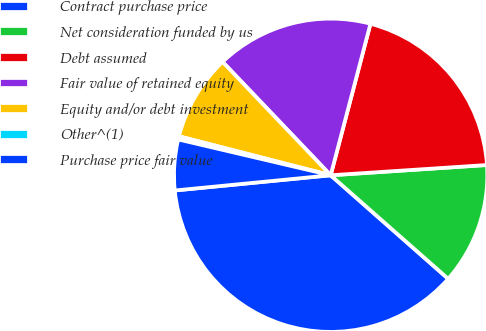Convert chart. <chart><loc_0><loc_0><loc_500><loc_500><pie_chart><fcel>Contract purchase price<fcel>Net consideration funded by us<fcel>Debt assumed<fcel>Fair value of retained equity<fcel>Equity and/or debt investment<fcel>Other^(1)<fcel>Purchase price fair value<nl><fcel>36.96%<fcel>12.54%<fcel>19.87%<fcel>16.21%<fcel>8.88%<fcel>0.33%<fcel>5.22%<nl></chart> 